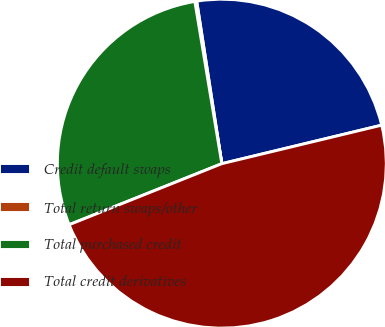Convert chart. <chart><loc_0><loc_0><loc_500><loc_500><pie_chart><fcel>Credit default swaps<fcel>Total return swaps/other<fcel>Total purchased credit<fcel>Total credit derivatives<nl><fcel>23.68%<fcel>0.18%<fcel>28.43%<fcel>47.71%<nl></chart> 